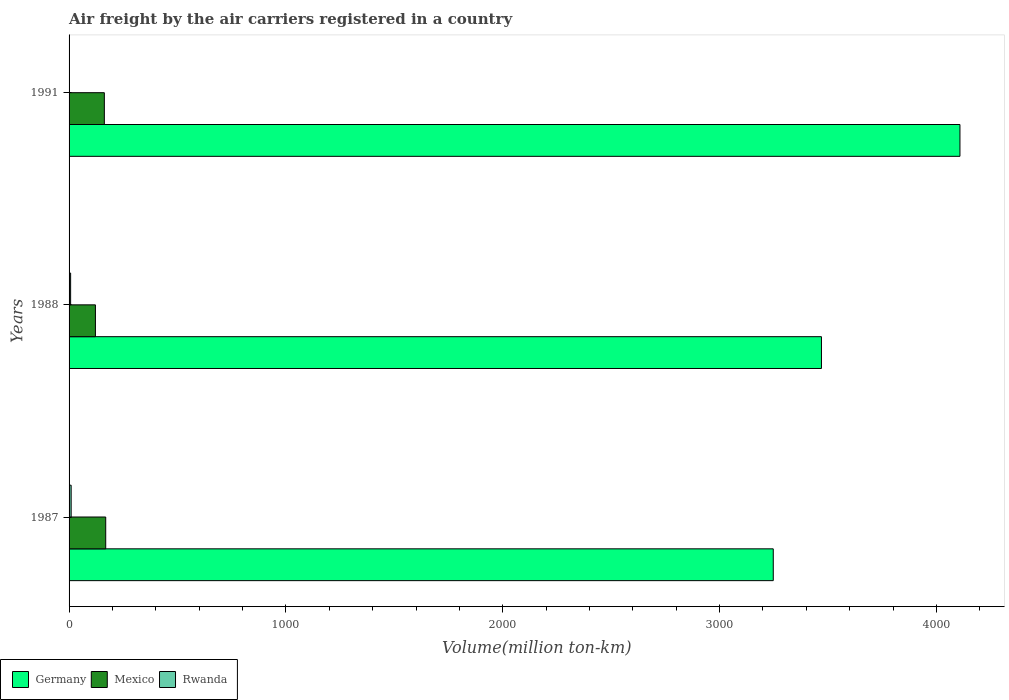What is the volume of the air carriers in Rwanda in 1991?
Your response must be concise. 1.2. Across all years, what is the maximum volume of the air carriers in Mexico?
Ensure brevity in your answer.  169. Across all years, what is the minimum volume of the air carriers in Germany?
Keep it short and to the point. 3247.7. In which year was the volume of the air carriers in Mexico minimum?
Your answer should be very brief. 1988. What is the total volume of the air carriers in Germany in the graph?
Give a very brief answer. 1.08e+04. What is the difference between the volume of the air carriers in Mexico in 1987 and that in 1988?
Keep it short and to the point. 47.5. What is the difference between the volume of the air carriers in Germany in 1987 and the volume of the air carriers in Rwanda in 1991?
Offer a terse response. 3246.5. What is the average volume of the air carriers in Germany per year?
Keep it short and to the point. 3608.8. In the year 1991, what is the difference between the volume of the air carriers in Rwanda and volume of the air carriers in Mexico?
Your answer should be very brief. -161.5. In how many years, is the volume of the air carriers in Mexico greater than 600 million ton-km?
Your answer should be compact. 0. What is the ratio of the volume of the air carriers in Germany in 1988 to that in 1991?
Keep it short and to the point. 0.84. Is the volume of the air carriers in Germany in 1987 less than that in 1991?
Your answer should be compact. Yes. Is the difference between the volume of the air carriers in Rwanda in 1987 and 1991 greater than the difference between the volume of the air carriers in Mexico in 1987 and 1991?
Ensure brevity in your answer.  Yes. What is the difference between the highest and the second highest volume of the air carriers in Germany?
Your answer should be compact. 638.7. What is the difference between the highest and the lowest volume of the air carriers in Rwanda?
Your answer should be compact. 8.4. In how many years, is the volume of the air carriers in Mexico greater than the average volume of the air carriers in Mexico taken over all years?
Provide a succinct answer. 2. What does the 1st bar from the top in 1987 represents?
Provide a short and direct response. Rwanda. Is it the case that in every year, the sum of the volume of the air carriers in Mexico and volume of the air carriers in Germany is greater than the volume of the air carriers in Rwanda?
Make the answer very short. Yes. Are all the bars in the graph horizontal?
Give a very brief answer. Yes. Are the values on the major ticks of X-axis written in scientific E-notation?
Offer a very short reply. No. Does the graph contain any zero values?
Ensure brevity in your answer.  No. How are the legend labels stacked?
Your answer should be very brief. Horizontal. What is the title of the graph?
Give a very brief answer. Air freight by the air carriers registered in a country. What is the label or title of the X-axis?
Give a very brief answer. Volume(million ton-km). What is the Volume(million ton-km) in Germany in 1987?
Keep it short and to the point. 3247.7. What is the Volume(million ton-km) in Mexico in 1987?
Offer a terse response. 169. What is the Volume(million ton-km) of Rwanda in 1987?
Provide a short and direct response. 9.6. What is the Volume(million ton-km) in Germany in 1988?
Keep it short and to the point. 3470. What is the Volume(million ton-km) of Mexico in 1988?
Your response must be concise. 121.5. What is the Volume(million ton-km) of Rwanda in 1988?
Make the answer very short. 7.2. What is the Volume(million ton-km) of Germany in 1991?
Your answer should be very brief. 4108.7. What is the Volume(million ton-km) in Mexico in 1991?
Make the answer very short. 162.7. What is the Volume(million ton-km) in Rwanda in 1991?
Offer a terse response. 1.2. Across all years, what is the maximum Volume(million ton-km) of Germany?
Make the answer very short. 4108.7. Across all years, what is the maximum Volume(million ton-km) in Mexico?
Your response must be concise. 169. Across all years, what is the maximum Volume(million ton-km) of Rwanda?
Ensure brevity in your answer.  9.6. Across all years, what is the minimum Volume(million ton-km) of Germany?
Give a very brief answer. 3247.7. Across all years, what is the minimum Volume(million ton-km) in Mexico?
Provide a short and direct response. 121.5. Across all years, what is the minimum Volume(million ton-km) in Rwanda?
Provide a short and direct response. 1.2. What is the total Volume(million ton-km) in Germany in the graph?
Provide a succinct answer. 1.08e+04. What is the total Volume(million ton-km) of Mexico in the graph?
Make the answer very short. 453.2. What is the total Volume(million ton-km) of Rwanda in the graph?
Keep it short and to the point. 18. What is the difference between the Volume(million ton-km) in Germany in 1987 and that in 1988?
Give a very brief answer. -222.3. What is the difference between the Volume(million ton-km) of Mexico in 1987 and that in 1988?
Ensure brevity in your answer.  47.5. What is the difference between the Volume(million ton-km) in Rwanda in 1987 and that in 1988?
Give a very brief answer. 2.4. What is the difference between the Volume(million ton-km) of Germany in 1987 and that in 1991?
Give a very brief answer. -861. What is the difference between the Volume(million ton-km) in Mexico in 1987 and that in 1991?
Make the answer very short. 6.3. What is the difference between the Volume(million ton-km) in Germany in 1988 and that in 1991?
Offer a very short reply. -638.7. What is the difference between the Volume(million ton-km) in Mexico in 1988 and that in 1991?
Your answer should be compact. -41.2. What is the difference between the Volume(million ton-km) of Germany in 1987 and the Volume(million ton-km) of Mexico in 1988?
Give a very brief answer. 3126.2. What is the difference between the Volume(million ton-km) of Germany in 1987 and the Volume(million ton-km) of Rwanda in 1988?
Your response must be concise. 3240.5. What is the difference between the Volume(million ton-km) of Mexico in 1987 and the Volume(million ton-km) of Rwanda in 1988?
Keep it short and to the point. 161.8. What is the difference between the Volume(million ton-km) in Germany in 1987 and the Volume(million ton-km) in Mexico in 1991?
Ensure brevity in your answer.  3085. What is the difference between the Volume(million ton-km) of Germany in 1987 and the Volume(million ton-km) of Rwanda in 1991?
Offer a very short reply. 3246.5. What is the difference between the Volume(million ton-km) in Mexico in 1987 and the Volume(million ton-km) in Rwanda in 1991?
Ensure brevity in your answer.  167.8. What is the difference between the Volume(million ton-km) of Germany in 1988 and the Volume(million ton-km) of Mexico in 1991?
Offer a terse response. 3307.3. What is the difference between the Volume(million ton-km) in Germany in 1988 and the Volume(million ton-km) in Rwanda in 1991?
Keep it short and to the point. 3468.8. What is the difference between the Volume(million ton-km) in Mexico in 1988 and the Volume(million ton-km) in Rwanda in 1991?
Offer a very short reply. 120.3. What is the average Volume(million ton-km) of Germany per year?
Your response must be concise. 3608.8. What is the average Volume(million ton-km) in Mexico per year?
Provide a succinct answer. 151.07. In the year 1987, what is the difference between the Volume(million ton-km) of Germany and Volume(million ton-km) of Mexico?
Offer a very short reply. 3078.7. In the year 1987, what is the difference between the Volume(million ton-km) in Germany and Volume(million ton-km) in Rwanda?
Give a very brief answer. 3238.1. In the year 1987, what is the difference between the Volume(million ton-km) in Mexico and Volume(million ton-km) in Rwanda?
Your response must be concise. 159.4. In the year 1988, what is the difference between the Volume(million ton-km) in Germany and Volume(million ton-km) in Mexico?
Provide a succinct answer. 3348.5. In the year 1988, what is the difference between the Volume(million ton-km) of Germany and Volume(million ton-km) of Rwanda?
Make the answer very short. 3462.8. In the year 1988, what is the difference between the Volume(million ton-km) in Mexico and Volume(million ton-km) in Rwanda?
Offer a terse response. 114.3. In the year 1991, what is the difference between the Volume(million ton-km) of Germany and Volume(million ton-km) of Mexico?
Provide a short and direct response. 3946. In the year 1991, what is the difference between the Volume(million ton-km) of Germany and Volume(million ton-km) of Rwanda?
Make the answer very short. 4107.5. In the year 1991, what is the difference between the Volume(million ton-km) in Mexico and Volume(million ton-km) in Rwanda?
Provide a short and direct response. 161.5. What is the ratio of the Volume(million ton-km) in Germany in 1987 to that in 1988?
Provide a succinct answer. 0.94. What is the ratio of the Volume(million ton-km) of Mexico in 1987 to that in 1988?
Your response must be concise. 1.39. What is the ratio of the Volume(million ton-km) in Rwanda in 1987 to that in 1988?
Your response must be concise. 1.33. What is the ratio of the Volume(million ton-km) in Germany in 1987 to that in 1991?
Your response must be concise. 0.79. What is the ratio of the Volume(million ton-km) of Mexico in 1987 to that in 1991?
Your response must be concise. 1.04. What is the ratio of the Volume(million ton-km) of Germany in 1988 to that in 1991?
Give a very brief answer. 0.84. What is the ratio of the Volume(million ton-km) of Mexico in 1988 to that in 1991?
Give a very brief answer. 0.75. What is the ratio of the Volume(million ton-km) of Rwanda in 1988 to that in 1991?
Give a very brief answer. 6. What is the difference between the highest and the second highest Volume(million ton-km) of Germany?
Offer a terse response. 638.7. What is the difference between the highest and the lowest Volume(million ton-km) in Germany?
Your answer should be compact. 861. What is the difference between the highest and the lowest Volume(million ton-km) in Mexico?
Your answer should be very brief. 47.5. What is the difference between the highest and the lowest Volume(million ton-km) of Rwanda?
Give a very brief answer. 8.4. 